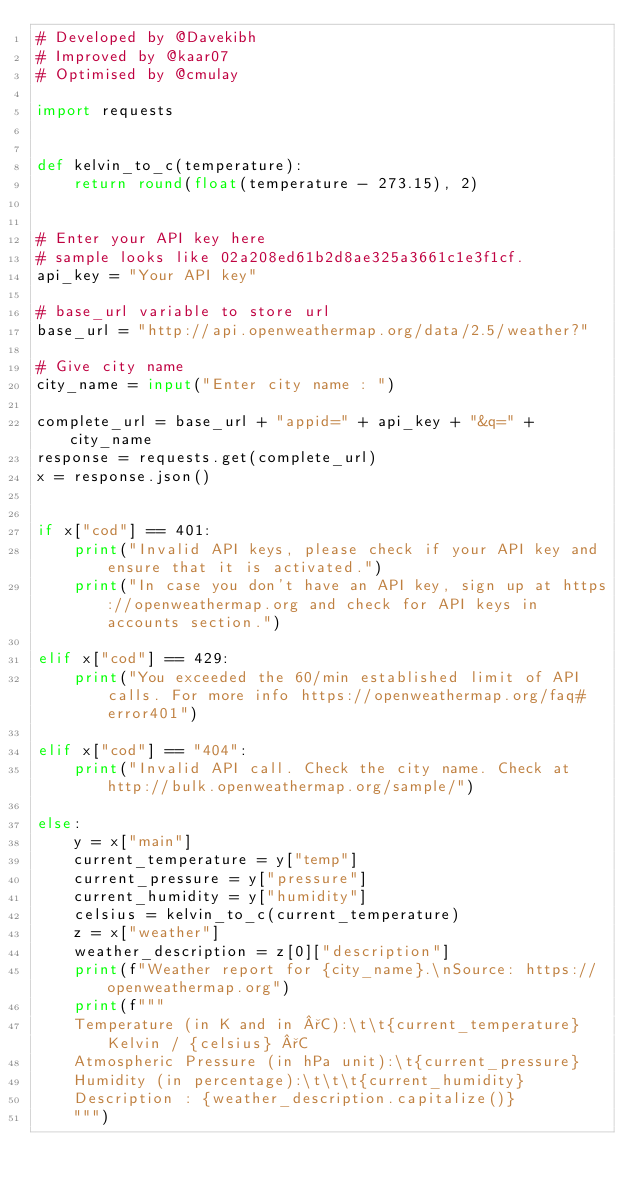Convert code to text. <code><loc_0><loc_0><loc_500><loc_500><_Python_># Developed by @Davekibh
# Improved by @kaar07
# Optimised by @cmulay

import requests


def kelvin_to_c(temperature):
    return round(float(temperature - 273.15), 2)


# Enter your API key here
# sample looks like 02a208ed61b2d8ae325a3661c1e3f1cf.
api_key = "Your API key"

# base_url variable to store url
base_url = "http://api.openweathermap.org/data/2.5/weather?"

# Give city name
city_name = input("Enter city name : ")

complete_url = base_url + "appid=" + api_key + "&q=" + city_name
response = requests.get(complete_url)
x = response.json()


if x["cod"] == 401:
    print("Invalid API keys, please check if your API key and ensure that it is activated.")
    print("In case you don't have an API key, sign up at https://openweathermap.org and check for API keys in accounts section.")

elif x["cod"] == 429:
    print("You exceeded the 60/min established limit of API calls. For more info https://openweathermap.org/faq#error401")

elif x["cod"] == "404":
    print("Invalid API call. Check the city name. Check at http://bulk.openweathermap.org/sample/")

else:
    y = x["main"]
    current_temperature = y["temp"]
    current_pressure = y["pressure"]
    current_humidity = y["humidity"]
    celsius = kelvin_to_c(current_temperature)
    z = x["weather"]
    weather_description = z[0]["description"]
    print(f"Weather report for {city_name}.\nSource: https://openweathermap.org")
    print(f"""
    Temperature (in K and in °C):\t\t{current_temperature} Kelvin / {celsius} °C
    Atmospheric Pressure (in hPa unit):\t{current_pressure}
    Humidity (in percentage):\t\t\t{current_humidity}
    Description : {weather_description.capitalize()}
    """)
</code> 